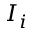<formula> <loc_0><loc_0><loc_500><loc_500>I _ { i }</formula> 